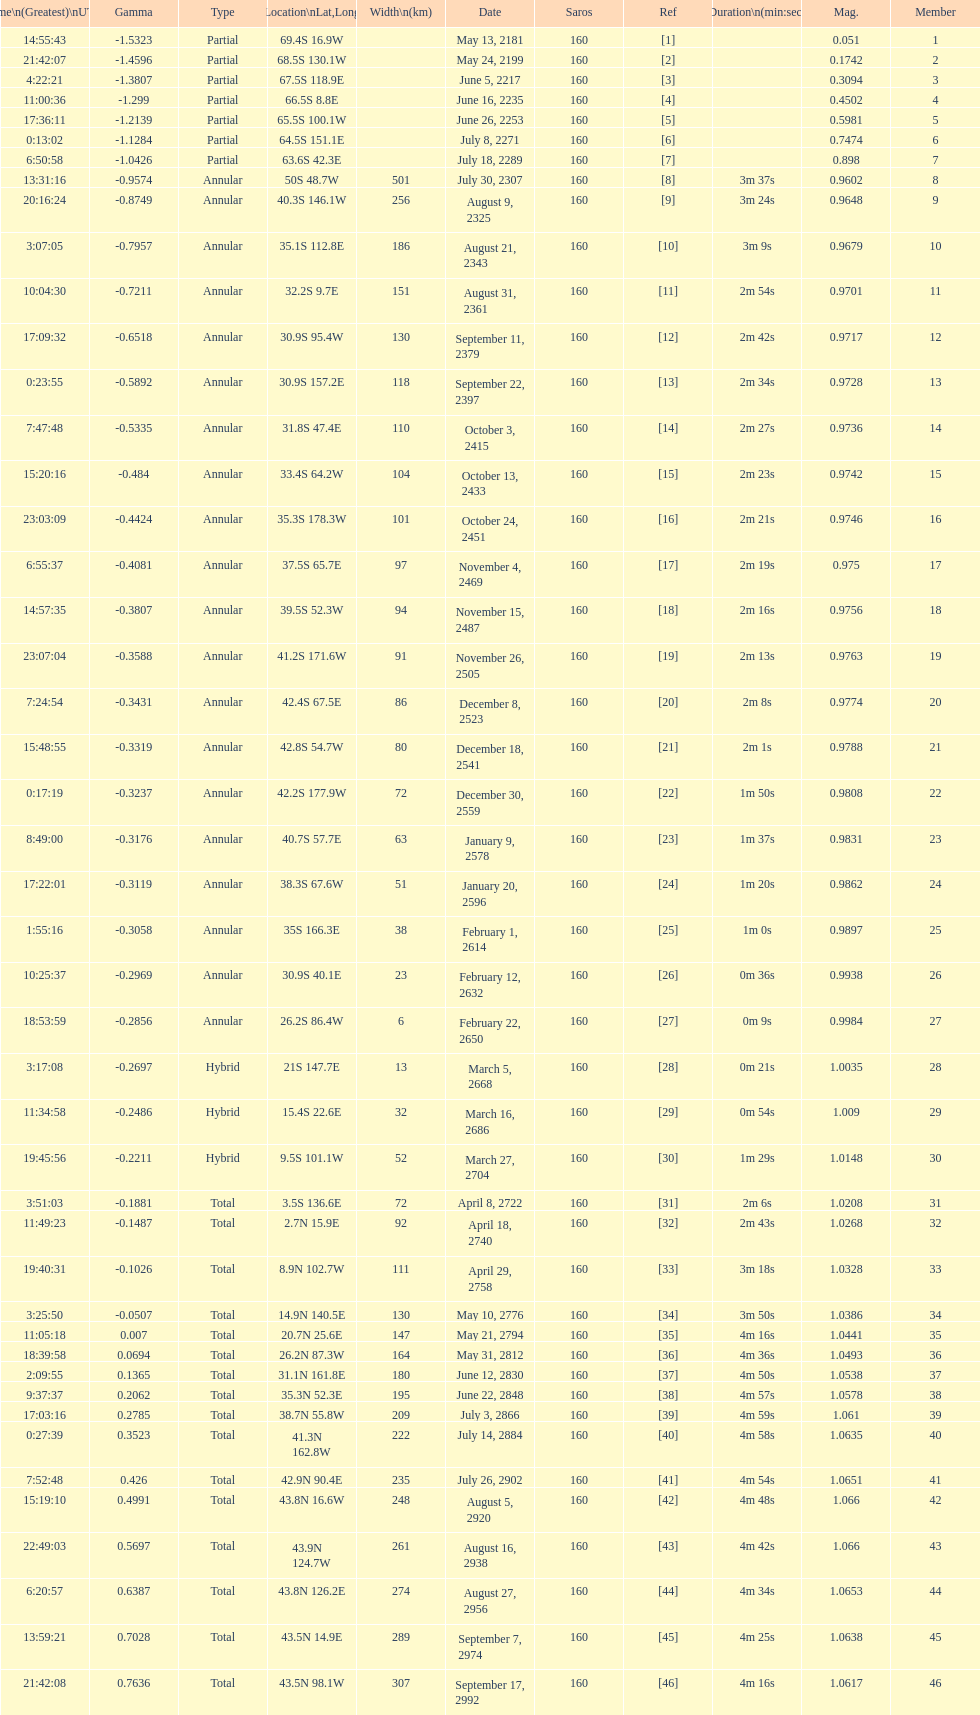What is the difference in magnitude between the may 13, 2181 solar saros and the may 24, 2199 solar saros? 0.1232. 